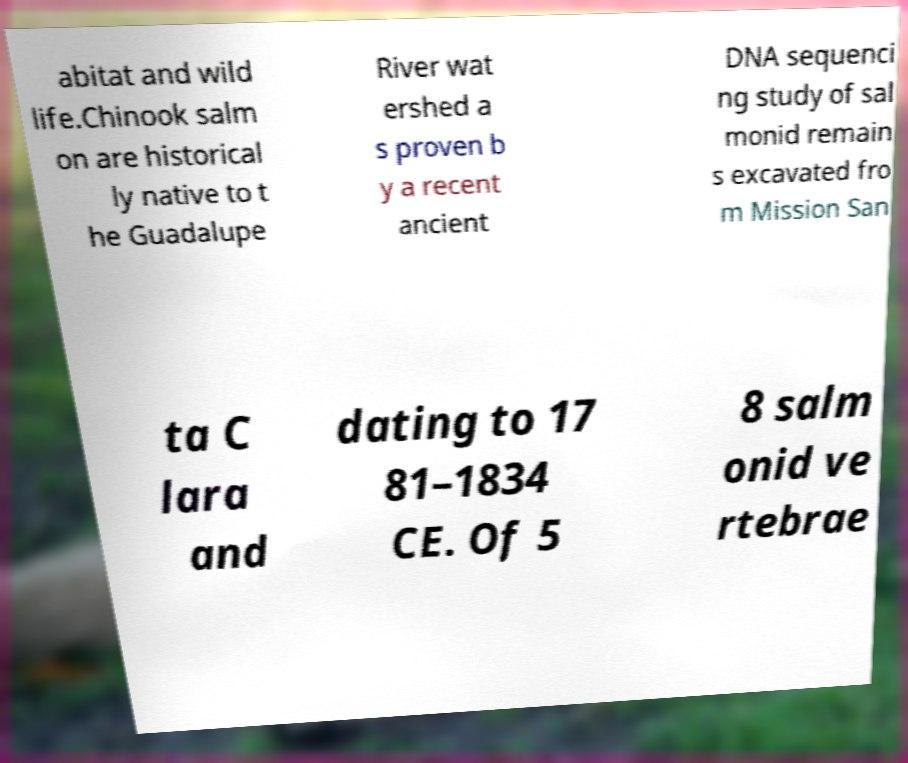Could you assist in decoding the text presented in this image and type it out clearly? abitat and wild life.Chinook salm on are historical ly native to t he Guadalupe River wat ershed a s proven b y a recent ancient DNA sequenci ng study of sal monid remain s excavated fro m Mission San ta C lara and dating to 17 81–1834 CE. Of 5 8 salm onid ve rtebrae 